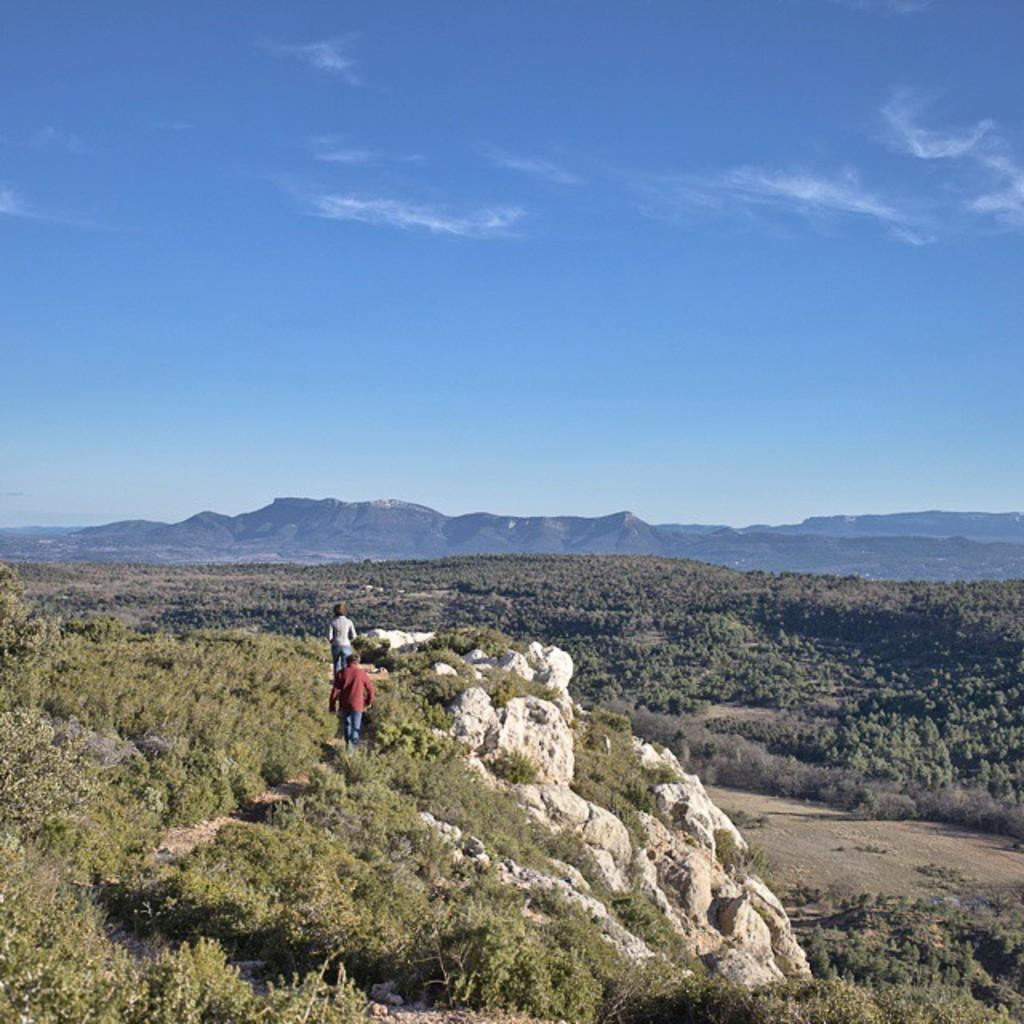Who or what can be seen in the image? There are people in the image. What other elements are present in the image besides people? There are plants, rocks, and trees in the image. What can be seen in the background of the image? In the background, there are hills and clouds. Where is the store located in the image? There is no store present in the image. Can you see a mitten on any of the people in the image? There is no mitten visible on any of the people in the image. 